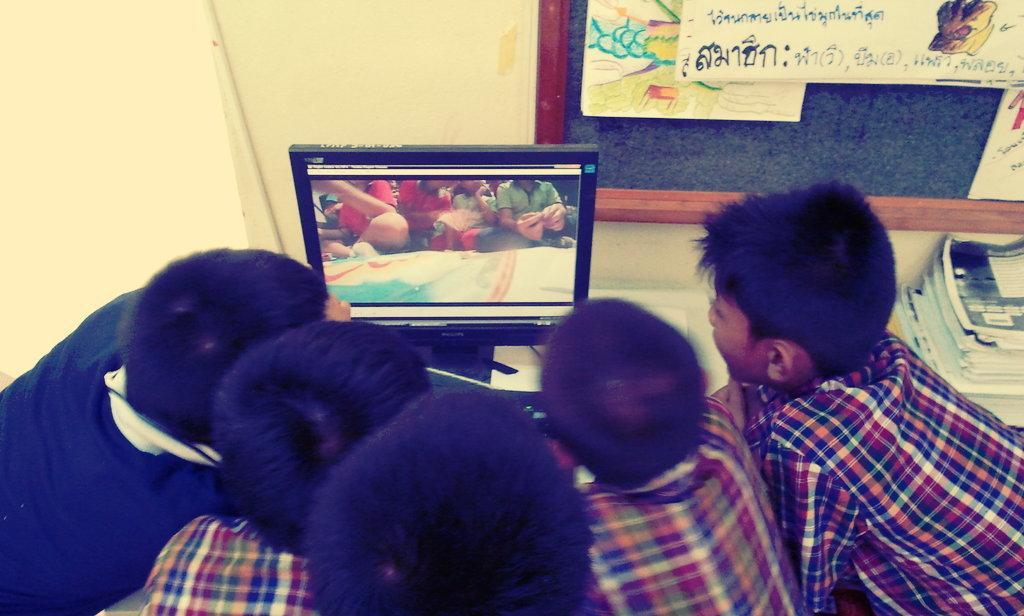Can you describe this image briefly? In this picture I can observe five children in front of a computer. On the right side I can observe some books placed on the desk. In the background I can observe noticeboard and a wall. 